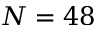<formula> <loc_0><loc_0><loc_500><loc_500>N = 4 8</formula> 